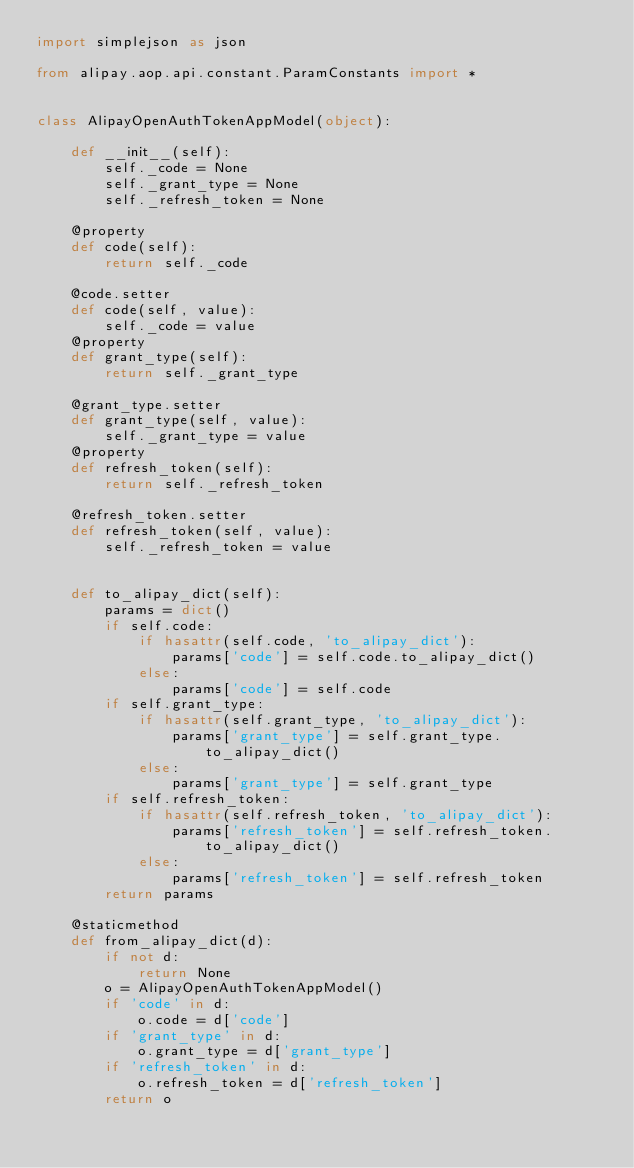<code> <loc_0><loc_0><loc_500><loc_500><_Python_>import simplejson as json

from alipay.aop.api.constant.ParamConstants import *


class AlipayOpenAuthTokenAppModel(object):

    def __init__(self):
        self._code = None
        self._grant_type = None
        self._refresh_token = None

    @property
    def code(self):
        return self._code

    @code.setter
    def code(self, value):
        self._code = value
    @property
    def grant_type(self):
        return self._grant_type

    @grant_type.setter
    def grant_type(self, value):
        self._grant_type = value
    @property
    def refresh_token(self):
        return self._refresh_token

    @refresh_token.setter
    def refresh_token(self, value):
        self._refresh_token = value


    def to_alipay_dict(self):
        params = dict()
        if self.code:
            if hasattr(self.code, 'to_alipay_dict'):
                params['code'] = self.code.to_alipay_dict()
            else:
                params['code'] = self.code
        if self.grant_type:
            if hasattr(self.grant_type, 'to_alipay_dict'):
                params['grant_type'] = self.grant_type.to_alipay_dict()
            else:
                params['grant_type'] = self.grant_type
        if self.refresh_token:
            if hasattr(self.refresh_token, 'to_alipay_dict'):
                params['refresh_token'] = self.refresh_token.to_alipay_dict()
            else:
                params['refresh_token'] = self.refresh_token
        return params

    @staticmethod
    def from_alipay_dict(d):
        if not d:
            return None
        o = AlipayOpenAuthTokenAppModel()
        if 'code' in d:
            o.code = d['code']
        if 'grant_type' in d:
            o.grant_type = d['grant_type']
        if 'refresh_token' in d:
            o.refresh_token = d['refresh_token']
        return o


</code> 